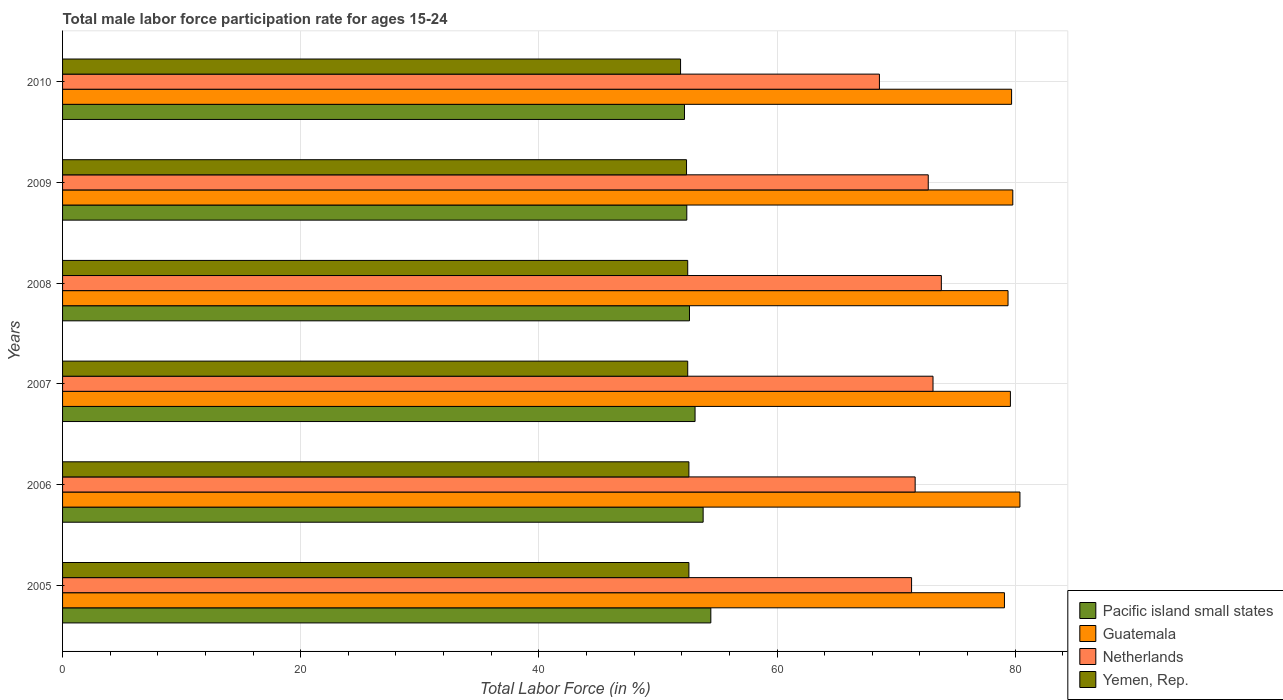How many different coloured bars are there?
Provide a short and direct response. 4. How many groups of bars are there?
Provide a short and direct response. 6. Are the number of bars on each tick of the Y-axis equal?
Your answer should be very brief. Yes. What is the male labor force participation rate in Netherlands in 2008?
Offer a terse response. 73.8. Across all years, what is the maximum male labor force participation rate in Guatemala?
Provide a succinct answer. 80.4. Across all years, what is the minimum male labor force participation rate in Pacific island small states?
Provide a short and direct response. 52.23. What is the total male labor force participation rate in Pacific island small states in the graph?
Ensure brevity in your answer.  318.65. What is the difference between the male labor force participation rate in Yemen, Rep. in 2005 and that in 2007?
Keep it short and to the point. 0.1. What is the difference between the male labor force participation rate in Pacific island small states in 2006 and the male labor force participation rate in Netherlands in 2010?
Provide a succinct answer. -14.8. What is the average male labor force participation rate in Netherlands per year?
Ensure brevity in your answer.  71.85. In the year 2010, what is the difference between the male labor force participation rate in Yemen, Rep. and male labor force participation rate in Pacific island small states?
Your answer should be compact. -0.33. What is the ratio of the male labor force participation rate in Guatemala in 2007 to that in 2009?
Your response must be concise. 1. What is the difference between the highest and the second highest male labor force participation rate in Pacific island small states?
Provide a succinct answer. 0.64. What is the difference between the highest and the lowest male labor force participation rate in Yemen, Rep.?
Ensure brevity in your answer.  0.7. In how many years, is the male labor force participation rate in Yemen, Rep. greater than the average male labor force participation rate in Yemen, Rep. taken over all years?
Ensure brevity in your answer.  4. What does the 1st bar from the top in 2010 represents?
Provide a succinct answer. Yemen, Rep. What does the 2nd bar from the bottom in 2006 represents?
Keep it short and to the point. Guatemala. Is it the case that in every year, the sum of the male labor force participation rate in Netherlands and male labor force participation rate in Guatemala is greater than the male labor force participation rate in Yemen, Rep.?
Offer a very short reply. Yes. How many bars are there?
Make the answer very short. 24. Are all the bars in the graph horizontal?
Make the answer very short. Yes. What is the difference between two consecutive major ticks on the X-axis?
Your answer should be compact. 20. Does the graph contain any zero values?
Offer a terse response. No. Does the graph contain grids?
Your answer should be very brief. Yes. What is the title of the graph?
Offer a terse response. Total male labor force participation rate for ages 15-24. What is the Total Labor Force (in %) in Pacific island small states in 2005?
Your answer should be very brief. 54.44. What is the Total Labor Force (in %) of Guatemala in 2005?
Your response must be concise. 79.1. What is the Total Labor Force (in %) in Netherlands in 2005?
Offer a very short reply. 71.3. What is the Total Labor Force (in %) in Yemen, Rep. in 2005?
Provide a succinct answer. 52.6. What is the Total Labor Force (in %) of Pacific island small states in 2006?
Offer a very short reply. 53.8. What is the Total Labor Force (in %) of Guatemala in 2006?
Give a very brief answer. 80.4. What is the Total Labor Force (in %) of Netherlands in 2006?
Ensure brevity in your answer.  71.6. What is the Total Labor Force (in %) in Yemen, Rep. in 2006?
Offer a terse response. 52.6. What is the Total Labor Force (in %) in Pacific island small states in 2007?
Your answer should be compact. 53.12. What is the Total Labor Force (in %) in Guatemala in 2007?
Ensure brevity in your answer.  79.6. What is the Total Labor Force (in %) in Netherlands in 2007?
Ensure brevity in your answer.  73.1. What is the Total Labor Force (in %) in Yemen, Rep. in 2007?
Ensure brevity in your answer.  52.5. What is the Total Labor Force (in %) in Pacific island small states in 2008?
Ensure brevity in your answer.  52.65. What is the Total Labor Force (in %) in Guatemala in 2008?
Provide a succinct answer. 79.4. What is the Total Labor Force (in %) of Netherlands in 2008?
Give a very brief answer. 73.8. What is the Total Labor Force (in %) in Yemen, Rep. in 2008?
Make the answer very short. 52.5. What is the Total Labor Force (in %) in Pacific island small states in 2009?
Offer a very short reply. 52.42. What is the Total Labor Force (in %) in Guatemala in 2009?
Provide a succinct answer. 79.8. What is the Total Labor Force (in %) of Netherlands in 2009?
Provide a short and direct response. 72.7. What is the Total Labor Force (in %) in Yemen, Rep. in 2009?
Ensure brevity in your answer.  52.4. What is the Total Labor Force (in %) in Pacific island small states in 2010?
Make the answer very short. 52.23. What is the Total Labor Force (in %) of Guatemala in 2010?
Ensure brevity in your answer.  79.7. What is the Total Labor Force (in %) of Netherlands in 2010?
Give a very brief answer. 68.6. What is the Total Labor Force (in %) in Yemen, Rep. in 2010?
Offer a terse response. 51.9. Across all years, what is the maximum Total Labor Force (in %) in Pacific island small states?
Your answer should be compact. 54.44. Across all years, what is the maximum Total Labor Force (in %) of Guatemala?
Provide a short and direct response. 80.4. Across all years, what is the maximum Total Labor Force (in %) of Netherlands?
Offer a very short reply. 73.8. Across all years, what is the maximum Total Labor Force (in %) in Yemen, Rep.?
Offer a very short reply. 52.6. Across all years, what is the minimum Total Labor Force (in %) in Pacific island small states?
Your response must be concise. 52.23. Across all years, what is the minimum Total Labor Force (in %) of Guatemala?
Offer a very short reply. 79.1. Across all years, what is the minimum Total Labor Force (in %) of Netherlands?
Provide a succinct answer. 68.6. Across all years, what is the minimum Total Labor Force (in %) of Yemen, Rep.?
Offer a very short reply. 51.9. What is the total Total Labor Force (in %) of Pacific island small states in the graph?
Provide a short and direct response. 318.65. What is the total Total Labor Force (in %) in Guatemala in the graph?
Keep it short and to the point. 478. What is the total Total Labor Force (in %) in Netherlands in the graph?
Your answer should be compact. 431.1. What is the total Total Labor Force (in %) of Yemen, Rep. in the graph?
Provide a succinct answer. 314.5. What is the difference between the Total Labor Force (in %) of Pacific island small states in 2005 and that in 2006?
Provide a succinct answer. 0.65. What is the difference between the Total Labor Force (in %) of Guatemala in 2005 and that in 2006?
Your answer should be compact. -1.3. What is the difference between the Total Labor Force (in %) of Netherlands in 2005 and that in 2006?
Your answer should be compact. -0.3. What is the difference between the Total Labor Force (in %) in Pacific island small states in 2005 and that in 2007?
Provide a short and direct response. 1.32. What is the difference between the Total Labor Force (in %) of Guatemala in 2005 and that in 2007?
Make the answer very short. -0.5. What is the difference between the Total Labor Force (in %) in Netherlands in 2005 and that in 2007?
Keep it short and to the point. -1.8. What is the difference between the Total Labor Force (in %) in Pacific island small states in 2005 and that in 2008?
Your response must be concise. 1.79. What is the difference between the Total Labor Force (in %) of Guatemala in 2005 and that in 2008?
Make the answer very short. -0.3. What is the difference between the Total Labor Force (in %) of Netherlands in 2005 and that in 2008?
Your answer should be compact. -2.5. What is the difference between the Total Labor Force (in %) of Pacific island small states in 2005 and that in 2009?
Offer a very short reply. 2.02. What is the difference between the Total Labor Force (in %) in Yemen, Rep. in 2005 and that in 2009?
Provide a succinct answer. 0.2. What is the difference between the Total Labor Force (in %) of Pacific island small states in 2005 and that in 2010?
Your answer should be very brief. 2.21. What is the difference between the Total Labor Force (in %) in Netherlands in 2005 and that in 2010?
Your answer should be very brief. 2.7. What is the difference between the Total Labor Force (in %) of Yemen, Rep. in 2005 and that in 2010?
Provide a short and direct response. 0.7. What is the difference between the Total Labor Force (in %) of Pacific island small states in 2006 and that in 2007?
Your answer should be very brief. 0.68. What is the difference between the Total Labor Force (in %) in Netherlands in 2006 and that in 2007?
Make the answer very short. -1.5. What is the difference between the Total Labor Force (in %) in Yemen, Rep. in 2006 and that in 2007?
Offer a very short reply. 0.1. What is the difference between the Total Labor Force (in %) in Pacific island small states in 2006 and that in 2008?
Offer a terse response. 1.15. What is the difference between the Total Labor Force (in %) in Guatemala in 2006 and that in 2008?
Keep it short and to the point. 1. What is the difference between the Total Labor Force (in %) in Yemen, Rep. in 2006 and that in 2008?
Offer a terse response. 0.1. What is the difference between the Total Labor Force (in %) of Pacific island small states in 2006 and that in 2009?
Your answer should be compact. 1.37. What is the difference between the Total Labor Force (in %) in Guatemala in 2006 and that in 2009?
Your response must be concise. 0.6. What is the difference between the Total Labor Force (in %) of Netherlands in 2006 and that in 2009?
Provide a short and direct response. -1.1. What is the difference between the Total Labor Force (in %) of Yemen, Rep. in 2006 and that in 2009?
Make the answer very short. 0.2. What is the difference between the Total Labor Force (in %) of Pacific island small states in 2006 and that in 2010?
Your answer should be very brief. 1.57. What is the difference between the Total Labor Force (in %) of Guatemala in 2006 and that in 2010?
Ensure brevity in your answer.  0.7. What is the difference between the Total Labor Force (in %) of Netherlands in 2006 and that in 2010?
Offer a very short reply. 3. What is the difference between the Total Labor Force (in %) in Pacific island small states in 2007 and that in 2008?
Offer a very short reply. 0.47. What is the difference between the Total Labor Force (in %) of Guatemala in 2007 and that in 2008?
Provide a succinct answer. 0.2. What is the difference between the Total Labor Force (in %) of Netherlands in 2007 and that in 2008?
Provide a succinct answer. -0.7. What is the difference between the Total Labor Force (in %) in Yemen, Rep. in 2007 and that in 2008?
Your answer should be very brief. 0. What is the difference between the Total Labor Force (in %) of Pacific island small states in 2007 and that in 2009?
Ensure brevity in your answer.  0.69. What is the difference between the Total Labor Force (in %) of Netherlands in 2007 and that in 2009?
Provide a succinct answer. 0.4. What is the difference between the Total Labor Force (in %) of Pacific island small states in 2007 and that in 2010?
Give a very brief answer. 0.89. What is the difference between the Total Labor Force (in %) of Netherlands in 2007 and that in 2010?
Offer a very short reply. 4.5. What is the difference between the Total Labor Force (in %) of Yemen, Rep. in 2007 and that in 2010?
Your response must be concise. 0.6. What is the difference between the Total Labor Force (in %) in Pacific island small states in 2008 and that in 2009?
Give a very brief answer. 0.23. What is the difference between the Total Labor Force (in %) in Guatemala in 2008 and that in 2009?
Offer a terse response. -0.4. What is the difference between the Total Labor Force (in %) of Yemen, Rep. in 2008 and that in 2009?
Offer a very short reply. 0.1. What is the difference between the Total Labor Force (in %) of Pacific island small states in 2008 and that in 2010?
Offer a very short reply. 0.42. What is the difference between the Total Labor Force (in %) of Guatemala in 2008 and that in 2010?
Keep it short and to the point. -0.3. What is the difference between the Total Labor Force (in %) in Netherlands in 2008 and that in 2010?
Offer a terse response. 5.2. What is the difference between the Total Labor Force (in %) of Yemen, Rep. in 2008 and that in 2010?
Your answer should be compact. 0.6. What is the difference between the Total Labor Force (in %) of Pacific island small states in 2009 and that in 2010?
Provide a succinct answer. 0.19. What is the difference between the Total Labor Force (in %) in Guatemala in 2009 and that in 2010?
Provide a succinct answer. 0.1. What is the difference between the Total Labor Force (in %) in Netherlands in 2009 and that in 2010?
Provide a succinct answer. 4.1. What is the difference between the Total Labor Force (in %) of Yemen, Rep. in 2009 and that in 2010?
Keep it short and to the point. 0.5. What is the difference between the Total Labor Force (in %) of Pacific island small states in 2005 and the Total Labor Force (in %) of Guatemala in 2006?
Keep it short and to the point. -25.96. What is the difference between the Total Labor Force (in %) in Pacific island small states in 2005 and the Total Labor Force (in %) in Netherlands in 2006?
Your response must be concise. -17.16. What is the difference between the Total Labor Force (in %) of Pacific island small states in 2005 and the Total Labor Force (in %) of Yemen, Rep. in 2006?
Provide a short and direct response. 1.84. What is the difference between the Total Labor Force (in %) of Guatemala in 2005 and the Total Labor Force (in %) of Netherlands in 2006?
Provide a short and direct response. 7.5. What is the difference between the Total Labor Force (in %) in Guatemala in 2005 and the Total Labor Force (in %) in Yemen, Rep. in 2006?
Keep it short and to the point. 26.5. What is the difference between the Total Labor Force (in %) of Netherlands in 2005 and the Total Labor Force (in %) of Yemen, Rep. in 2006?
Keep it short and to the point. 18.7. What is the difference between the Total Labor Force (in %) in Pacific island small states in 2005 and the Total Labor Force (in %) in Guatemala in 2007?
Your answer should be compact. -25.16. What is the difference between the Total Labor Force (in %) in Pacific island small states in 2005 and the Total Labor Force (in %) in Netherlands in 2007?
Offer a terse response. -18.66. What is the difference between the Total Labor Force (in %) in Pacific island small states in 2005 and the Total Labor Force (in %) in Yemen, Rep. in 2007?
Give a very brief answer. 1.94. What is the difference between the Total Labor Force (in %) in Guatemala in 2005 and the Total Labor Force (in %) in Netherlands in 2007?
Ensure brevity in your answer.  6. What is the difference between the Total Labor Force (in %) in Guatemala in 2005 and the Total Labor Force (in %) in Yemen, Rep. in 2007?
Your answer should be compact. 26.6. What is the difference between the Total Labor Force (in %) of Pacific island small states in 2005 and the Total Labor Force (in %) of Guatemala in 2008?
Offer a terse response. -24.96. What is the difference between the Total Labor Force (in %) of Pacific island small states in 2005 and the Total Labor Force (in %) of Netherlands in 2008?
Keep it short and to the point. -19.36. What is the difference between the Total Labor Force (in %) in Pacific island small states in 2005 and the Total Labor Force (in %) in Yemen, Rep. in 2008?
Provide a succinct answer. 1.94. What is the difference between the Total Labor Force (in %) in Guatemala in 2005 and the Total Labor Force (in %) in Yemen, Rep. in 2008?
Your response must be concise. 26.6. What is the difference between the Total Labor Force (in %) of Pacific island small states in 2005 and the Total Labor Force (in %) of Guatemala in 2009?
Your answer should be compact. -25.36. What is the difference between the Total Labor Force (in %) in Pacific island small states in 2005 and the Total Labor Force (in %) in Netherlands in 2009?
Provide a succinct answer. -18.26. What is the difference between the Total Labor Force (in %) of Pacific island small states in 2005 and the Total Labor Force (in %) of Yemen, Rep. in 2009?
Your response must be concise. 2.04. What is the difference between the Total Labor Force (in %) in Guatemala in 2005 and the Total Labor Force (in %) in Netherlands in 2009?
Keep it short and to the point. 6.4. What is the difference between the Total Labor Force (in %) of Guatemala in 2005 and the Total Labor Force (in %) of Yemen, Rep. in 2009?
Your answer should be very brief. 26.7. What is the difference between the Total Labor Force (in %) of Pacific island small states in 2005 and the Total Labor Force (in %) of Guatemala in 2010?
Give a very brief answer. -25.26. What is the difference between the Total Labor Force (in %) in Pacific island small states in 2005 and the Total Labor Force (in %) in Netherlands in 2010?
Give a very brief answer. -14.16. What is the difference between the Total Labor Force (in %) of Pacific island small states in 2005 and the Total Labor Force (in %) of Yemen, Rep. in 2010?
Offer a terse response. 2.54. What is the difference between the Total Labor Force (in %) of Guatemala in 2005 and the Total Labor Force (in %) of Netherlands in 2010?
Offer a very short reply. 10.5. What is the difference between the Total Labor Force (in %) in Guatemala in 2005 and the Total Labor Force (in %) in Yemen, Rep. in 2010?
Provide a short and direct response. 27.2. What is the difference between the Total Labor Force (in %) in Pacific island small states in 2006 and the Total Labor Force (in %) in Guatemala in 2007?
Keep it short and to the point. -25.8. What is the difference between the Total Labor Force (in %) in Pacific island small states in 2006 and the Total Labor Force (in %) in Netherlands in 2007?
Your answer should be very brief. -19.3. What is the difference between the Total Labor Force (in %) of Pacific island small states in 2006 and the Total Labor Force (in %) of Yemen, Rep. in 2007?
Offer a very short reply. 1.3. What is the difference between the Total Labor Force (in %) in Guatemala in 2006 and the Total Labor Force (in %) in Yemen, Rep. in 2007?
Your answer should be compact. 27.9. What is the difference between the Total Labor Force (in %) in Pacific island small states in 2006 and the Total Labor Force (in %) in Guatemala in 2008?
Your answer should be very brief. -25.6. What is the difference between the Total Labor Force (in %) in Pacific island small states in 2006 and the Total Labor Force (in %) in Netherlands in 2008?
Ensure brevity in your answer.  -20. What is the difference between the Total Labor Force (in %) of Pacific island small states in 2006 and the Total Labor Force (in %) of Yemen, Rep. in 2008?
Make the answer very short. 1.3. What is the difference between the Total Labor Force (in %) in Guatemala in 2006 and the Total Labor Force (in %) in Yemen, Rep. in 2008?
Offer a very short reply. 27.9. What is the difference between the Total Labor Force (in %) in Pacific island small states in 2006 and the Total Labor Force (in %) in Guatemala in 2009?
Your answer should be very brief. -26. What is the difference between the Total Labor Force (in %) in Pacific island small states in 2006 and the Total Labor Force (in %) in Netherlands in 2009?
Your answer should be compact. -18.9. What is the difference between the Total Labor Force (in %) in Pacific island small states in 2006 and the Total Labor Force (in %) in Yemen, Rep. in 2009?
Give a very brief answer. 1.4. What is the difference between the Total Labor Force (in %) of Guatemala in 2006 and the Total Labor Force (in %) of Yemen, Rep. in 2009?
Offer a terse response. 28. What is the difference between the Total Labor Force (in %) in Netherlands in 2006 and the Total Labor Force (in %) in Yemen, Rep. in 2009?
Provide a succinct answer. 19.2. What is the difference between the Total Labor Force (in %) in Pacific island small states in 2006 and the Total Labor Force (in %) in Guatemala in 2010?
Offer a very short reply. -25.9. What is the difference between the Total Labor Force (in %) of Pacific island small states in 2006 and the Total Labor Force (in %) of Netherlands in 2010?
Keep it short and to the point. -14.8. What is the difference between the Total Labor Force (in %) of Pacific island small states in 2006 and the Total Labor Force (in %) of Yemen, Rep. in 2010?
Keep it short and to the point. 1.9. What is the difference between the Total Labor Force (in %) in Guatemala in 2006 and the Total Labor Force (in %) in Yemen, Rep. in 2010?
Your answer should be compact. 28.5. What is the difference between the Total Labor Force (in %) of Netherlands in 2006 and the Total Labor Force (in %) of Yemen, Rep. in 2010?
Your response must be concise. 19.7. What is the difference between the Total Labor Force (in %) of Pacific island small states in 2007 and the Total Labor Force (in %) of Guatemala in 2008?
Make the answer very short. -26.28. What is the difference between the Total Labor Force (in %) of Pacific island small states in 2007 and the Total Labor Force (in %) of Netherlands in 2008?
Ensure brevity in your answer.  -20.68. What is the difference between the Total Labor Force (in %) in Pacific island small states in 2007 and the Total Labor Force (in %) in Yemen, Rep. in 2008?
Give a very brief answer. 0.62. What is the difference between the Total Labor Force (in %) of Guatemala in 2007 and the Total Labor Force (in %) of Netherlands in 2008?
Ensure brevity in your answer.  5.8. What is the difference between the Total Labor Force (in %) in Guatemala in 2007 and the Total Labor Force (in %) in Yemen, Rep. in 2008?
Provide a succinct answer. 27.1. What is the difference between the Total Labor Force (in %) of Netherlands in 2007 and the Total Labor Force (in %) of Yemen, Rep. in 2008?
Give a very brief answer. 20.6. What is the difference between the Total Labor Force (in %) of Pacific island small states in 2007 and the Total Labor Force (in %) of Guatemala in 2009?
Ensure brevity in your answer.  -26.68. What is the difference between the Total Labor Force (in %) of Pacific island small states in 2007 and the Total Labor Force (in %) of Netherlands in 2009?
Give a very brief answer. -19.58. What is the difference between the Total Labor Force (in %) of Pacific island small states in 2007 and the Total Labor Force (in %) of Yemen, Rep. in 2009?
Provide a succinct answer. 0.72. What is the difference between the Total Labor Force (in %) in Guatemala in 2007 and the Total Labor Force (in %) in Netherlands in 2009?
Offer a very short reply. 6.9. What is the difference between the Total Labor Force (in %) of Guatemala in 2007 and the Total Labor Force (in %) of Yemen, Rep. in 2009?
Offer a terse response. 27.2. What is the difference between the Total Labor Force (in %) in Netherlands in 2007 and the Total Labor Force (in %) in Yemen, Rep. in 2009?
Your answer should be very brief. 20.7. What is the difference between the Total Labor Force (in %) of Pacific island small states in 2007 and the Total Labor Force (in %) of Guatemala in 2010?
Your answer should be compact. -26.58. What is the difference between the Total Labor Force (in %) of Pacific island small states in 2007 and the Total Labor Force (in %) of Netherlands in 2010?
Your answer should be compact. -15.48. What is the difference between the Total Labor Force (in %) in Pacific island small states in 2007 and the Total Labor Force (in %) in Yemen, Rep. in 2010?
Keep it short and to the point. 1.22. What is the difference between the Total Labor Force (in %) in Guatemala in 2007 and the Total Labor Force (in %) in Netherlands in 2010?
Offer a very short reply. 11. What is the difference between the Total Labor Force (in %) of Guatemala in 2007 and the Total Labor Force (in %) of Yemen, Rep. in 2010?
Your response must be concise. 27.7. What is the difference between the Total Labor Force (in %) in Netherlands in 2007 and the Total Labor Force (in %) in Yemen, Rep. in 2010?
Your answer should be very brief. 21.2. What is the difference between the Total Labor Force (in %) in Pacific island small states in 2008 and the Total Labor Force (in %) in Guatemala in 2009?
Offer a very short reply. -27.15. What is the difference between the Total Labor Force (in %) of Pacific island small states in 2008 and the Total Labor Force (in %) of Netherlands in 2009?
Offer a terse response. -20.05. What is the difference between the Total Labor Force (in %) of Pacific island small states in 2008 and the Total Labor Force (in %) of Yemen, Rep. in 2009?
Offer a very short reply. 0.25. What is the difference between the Total Labor Force (in %) of Netherlands in 2008 and the Total Labor Force (in %) of Yemen, Rep. in 2009?
Keep it short and to the point. 21.4. What is the difference between the Total Labor Force (in %) of Pacific island small states in 2008 and the Total Labor Force (in %) of Guatemala in 2010?
Your answer should be very brief. -27.05. What is the difference between the Total Labor Force (in %) in Pacific island small states in 2008 and the Total Labor Force (in %) in Netherlands in 2010?
Ensure brevity in your answer.  -15.95. What is the difference between the Total Labor Force (in %) in Pacific island small states in 2008 and the Total Labor Force (in %) in Yemen, Rep. in 2010?
Your answer should be very brief. 0.75. What is the difference between the Total Labor Force (in %) in Guatemala in 2008 and the Total Labor Force (in %) in Netherlands in 2010?
Make the answer very short. 10.8. What is the difference between the Total Labor Force (in %) of Guatemala in 2008 and the Total Labor Force (in %) of Yemen, Rep. in 2010?
Make the answer very short. 27.5. What is the difference between the Total Labor Force (in %) in Netherlands in 2008 and the Total Labor Force (in %) in Yemen, Rep. in 2010?
Give a very brief answer. 21.9. What is the difference between the Total Labor Force (in %) in Pacific island small states in 2009 and the Total Labor Force (in %) in Guatemala in 2010?
Provide a short and direct response. -27.28. What is the difference between the Total Labor Force (in %) of Pacific island small states in 2009 and the Total Labor Force (in %) of Netherlands in 2010?
Your answer should be compact. -16.18. What is the difference between the Total Labor Force (in %) in Pacific island small states in 2009 and the Total Labor Force (in %) in Yemen, Rep. in 2010?
Provide a succinct answer. 0.52. What is the difference between the Total Labor Force (in %) in Guatemala in 2009 and the Total Labor Force (in %) in Yemen, Rep. in 2010?
Make the answer very short. 27.9. What is the difference between the Total Labor Force (in %) in Netherlands in 2009 and the Total Labor Force (in %) in Yemen, Rep. in 2010?
Keep it short and to the point. 20.8. What is the average Total Labor Force (in %) of Pacific island small states per year?
Offer a terse response. 53.11. What is the average Total Labor Force (in %) of Guatemala per year?
Provide a succinct answer. 79.67. What is the average Total Labor Force (in %) of Netherlands per year?
Offer a very short reply. 71.85. What is the average Total Labor Force (in %) of Yemen, Rep. per year?
Ensure brevity in your answer.  52.42. In the year 2005, what is the difference between the Total Labor Force (in %) in Pacific island small states and Total Labor Force (in %) in Guatemala?
Ensure brevity in your answer.  -24.66. In the year 2005, what is the difference between the Total Labor Force (in %) of Pacific island small states and Total Labor Force (in %) of Netherlands?
Your response must be concise. -16.86. In the year 2005, what is the difference between the Total Labor Force (in %) in Pacific island small states and Total Labor Force (in %) in Yemen, Rep.?
Make the answer very short. 1.84. In the year 2005, what is the difference between the Total Labor Force (in %) in Guatemala and Total Labor Force (in %) in Netherlands?
Your answer should be very brief. 7.8. In the year 2005, what is the difference between the Total Labor Force (in %) of Guatemala and Total Labor Force (in %) of Yemen, Rep.?
Provide a succinct answer. 26.5. In the year 2005, what is the difference between the Total Labor Force (in %) of Netherlands and Total Labor Force (in %) of Yemen, Rep.?
Give a very brief answer. 18.7. In the year 2006, what is the difference between the Total Labor Force (in %) of Pacific island small states and Total Labor Force (in %) of Guatemala?
Provide a short and direct response. -26.6. In the year 2006, what is the difference between the Total Labor Force (in %) of Pacific island small states and Total Labor Force (in %) of Netherlands?
Offer a very short reply. -17.8. In the year 2006, what is the difference between the Total Labor Force (in %) in Pacific island small states and Total Labor Force (in %) in Yemen, Rep.?
Your answer should be compact. 1.2. In the year 2006, what is the difference between the Total Labor Force (in %) of Guatemala and Total Labor Force (in %) of Yemen, Rep.?
Your answer should be very brief. 27.8. In the year 2007, what is the difference between the Total Labor Force (in %) in Pacific island small states and Total Labor Force (in %) in Guatemala?
Your response must be concise. -26.48. In the year 2007, what is the difference between the Total Labor Force (in %) of Pacific island small states and Total Labor Force (in %) of Netherlands?
Your response must be concise. -19.98. In the year 2007, what is the difference between the Total Labor Force (in %) in Pacific island small states and Total Labor Force (in %) in Yemen, Rep.?
Provide a short and direct response. 0.62. In the year 2007, what is the difference between the Total Labor Force (in %) of Guatemala and Total Labor Force (in %) of Netherlands?
Your answer should be very brief. 6.5. In the year 2007, what is the difference between the Total Labor Force (in %) of Guatemala and Total Labor Force (in %) of Yemen, Rep.?
Provide a short and direct response. 27.1. In the year 2007, what is the difference between the Total Labor Force (in %) in Netherlands and Total Labor Force (in %) in Yemen, Rep.?
Provide a short and direct response. 20.6. In the year 2008, what is the difference between the Total Labor Force (in %) in Pacific island small states and Total Labor Force (in %) in Guatemala?
Make the answer very short. -26.75. In the year 2008, what is the difference between the Total Labor Force (in %) of Pacific island small states and Total Labor Force (in %) of Netherlands?
Ensure brevity in your answer.  -21.15. In the year 2008, what is the difference between the Total Labor Force (in %) of Pacific island small states and Total Labor Force (in %) of Yemen, Rep.?
Your answer should be very brief. 0.15. In the year 2008, what is the difference between the Total Labor Force (in %) of Guatemala and Total Labor Force (in %) of Netherlands?
Provide a succinct answer. 5.6. In the year 2008, what is the difference between the Total Labor Force (in %) of Guatemala and Total Labor Force (in %) of Yemen, Rep.?
Offer a terse response. 26.9. In the year 2008, what is the difference between the Total Labor Force (in %) in Netherlands and Total Labor Force (in %) in Yemen, Rep.?
Give a very brief answer. 21.3. In the year 2009, what is the difference between the Total Labor Force (in %) in Pacific island small states and Total Labor Force (in %) in Guatemala?
Your response must be concise. -27.38. In the year 2009, what is the difference between the Total Labor Force (in %) of Pacific island small states and Total Labor Force (in %) of Netherlands?
Give a very brief answer. -20.28. In the year 2009, what is the difference between the Total Labor Force (in %) in Pacific island small states and Total Labor Force (in %) in Yemen, Rep.?
Provide a short and direct response. 0.02. In the year 2009, what is the difference between the Total Labor Force (in %) of Guatemala and Total Labor Force (in %) of Yemen, Rep.?
Your answer should be very brief. 27.4. In the year 2009, what is the difference between the Total Labor Force (in %) in Netherlands and Total Labor Force (in %) in Yemen, Rep.?
Make the answer very short. 20.3. In the year 2010, what is the difference between the Total Labor Force (in %) in Pacific island small states and Total Labor Force (in %) in Guatemala?
Offer a very short reply. -27.47. In the year 2010, what is the difference between the Total Labor Force (in %) in Pacific island small states and Total Labor Force (in %) in Netherlands?
Your answer should be compact. -16.37. In the year 2010, what is the difference between the Total Labor Force (in %) in Pacific island small states and Total Labor Force (in %) in Yemen, Rep.?
Your answer should be compact. 0.33. In the year 2010, what is the difference between the Total Labor Force (in %) of Guatemala and Total Labor Force (in %) of Yemen, Rep.?
Give a very brief answer. 27.8. In the year 2010, what is the difference between the Total Labor Force (in %) of Netherlands and Total Labor Force (in %) of Yemen, Rep.?
Your answer should be compact. 16.7. What is the ratio of the Total Labor Force (in %) in Guatemala in 2005 to that in 2006?
Offer a terse response. 0.98. What is the ratio of the Total Labor Force (in %) in Netherlands in 2005 to that in 2006?
Provide a succinct answer. 1. What is the ratio of the Total Labor Force (in %) of Yemen, Rep. in 2005 to that in 2006?
Ensure brevity in your answer.  1. What is the ratio of the Total Labor Force (in %) of Pacific island small states in 2005 to that in 2007?
Your answer should be very brief. 1.02. What is the ratio of the Total Labor Force (in %) of Netherlands in 2005 to that in 2007?
Offer a very short reply. 0.98. What is the ratio of the Total Labor Force (in %) in Pacific island small states in 2005 to that in 2008?
Make the answer very short. 1.03. What is the ratio of the Total Labor Force (in %) in Guatemala in 2005 to that in 2008?
Give a very brief answer. 1. What is the ratio of the Total Labor Force (in %) in Netherlands in 2005 to that in 2008?
Provide a succinct answer. 0.97. What is the ratio of the Total Labor Force (in %) in Yemen, Rep. in 2005 to that in 2008?
Keep it short and to the point. 1. What is the ratio of the Total Labor Force (in %) in Netherlands in 2005 to that in 2009?
Ensure brevity in your answer.  0.98. What is the ratio of the Total Labor Force (in %) in Pacific island small states in 2005 to that in 2010?
Offer a very short reply. 1.04. What is the ratio of the Total Labor Force (in %) in Guatemala in 2005 to that in 2010?
Your answer should be very brief. 0.99. What is the ratio of the Total Labor Force (in %) in Netherlands in 2005 to that in 2010?
Your answer should be compact. 1.04. What is the ratio of the Total Labor Force (in %) in Yemen, Rep. in 2005 to that in 2010?
Offer a terse response. 1.01. What is the ratio of the Total Labor Force (in %) of Pacific island small states in 2006 to that in 2007?
Keep it short and to the point. 1.01. What is the ratio of the Total Labor Force (in %) of Netherlands in 2006 to that in 2007?
Make the answer very short. 0.98. What is the ratio of the Total Labor Force (in %) of Pacific island small states in 2006 to that in 2008?
Provide a succinct answer. 1.02. What is the ratio of the Total Labor Force (in %) of Guatemala in 2006 to that in 2008?
Ensure brevity in your answer.  1.01. What is the ratio of the Total Labor Force (in %) in Netherlands in 2006 to that in 2008?
Provide a succinct answer. 0.97. What is the ratio of the Total Labor Force (in %) in Pacific island small states in 2006 to that in 2009?
Offer a very short reply. 1.03. What is the ratio of the Total Labor Force (in %) in Guatemala in 2006 to that in 2009?
Ensure brevity in your answer.  1.01. What is the ratio of the Total Labor Force (in %) in Netherlands in 2006 to that in 2009?
Make the answer very short. 0.98. What is the ratio of the Total Labor Force (in %) of Yemen, Rep. in 2006 to that in 2009?
Give a very brief answer. 1. What is the ratio of the Total Labor Force (in %) of Guatemala in 2006 to that in 2010?
Make the answer very short. 1.01. What is the ratio of the Total Labor Force (in %) in Netherlands in 2006 to that in 2010?
Your answer should be very brief. 1.04. What is the ratio of the Total Labor Force (in %) in Yemen, Rep. in 2006 to that in 2010?
Provide a short and direct response. 1.01. What is the ratio of the Total Labor Force (in %) of Pacific island small states in 2007 to that in 2008?
Your answer should be very brief. 1.01. What is the ratio of the Total Labor Force (in %) of Guatemala in 2007 to that in 2008?
Your answer should be compact. 1. What is the ratio of the Total Labor Force (in %) in Pacific island small states in 2007 to that in 2009?
Your answer should be compact. 1.01. What is the ratio of the Total Labor Force (in %) of Netherlands in 2007 to that in 2009?
Offer a very short reply. 1.01. What is the ratio of the Total Labor Force (in %) of Yemen, Rep. in 2007 to that in 2009?
Make the answer very short. 1. What is the ratio of the Total Labor Force (in %) of Pacific island small states in 2007 to that in 2010?
Give a very brief answer. 1.02. What is the ratio of the Total Labor Force (in %) of Netherlands in 2007 to that in 2010?
Provide a succinct answer. 1.07. What is the ratio of the Total Labor Force (in %) in Yemen, Rep. in 2007 to that in 2010?
Your response must be concise. 1.01. What is the ratio of the Total Labor Force (in %) in Pacific island small states in 2008 to that in 2009?
Your answer should be very brief. 1. What is the ratio of the Total Labor Force (in %) of Netherlands in 2008 to that in 2009?
Provide a succinct answer. 1.02. What is the ratio of the Total Labor Force (in %) in Yemen, Rep. in 2008 to that in 2009?
Provide a short and direct response. 1. What is the ratio of the Total Labor Force (in %) of Netherlands in 2008 to that in 2010?
Your response must be concise. 1.08. What is the ratio of the Total Labor Force (in %) of Yemen, Rep. in 2008 to that in 2010?
Provide a succinct answer. 1.01. What is the ratio of the Total Labor Force (in %) of Guatemala in 2009 to that in 2010?
Your answer should be very brief. 1. What is the ratio of the Total Labor Force (in %) in Netherlands in 2009 to that in 2010?
Provide a short and direct response. 1.06. What is the ratio of the Total Labor Force (in %) of Yemen, Rep. in 2009 to that in 2010?
Give a very brief answer. 1.01. What is the difference between the highest and the second highest Total Labor Force (in %) in Pacific island small states?
Provide a succinct answer. 0.65. What is the difference between the highest and the second highest Total Labor Force (in %) of Guatemala?
Give a very brief answer. 0.6. What is the difference between the highest and the second highest Total Labor Force (in %) of Netherlands?
Provide a succinct answer. 0.7. What is the difference between the highest and the lowest Total Labor Force (in %) in Pacific island small states?
Offer a very short reply. 2.21. What is the difference between the highest and the lowest Total Labor Force (in %) in Guatemala?
Give a very brief answer. 1.3. What is the difference between the highest and the lowest Total Labor Force (in %) in Netherlands?
Offer a terse response. 5.2. 